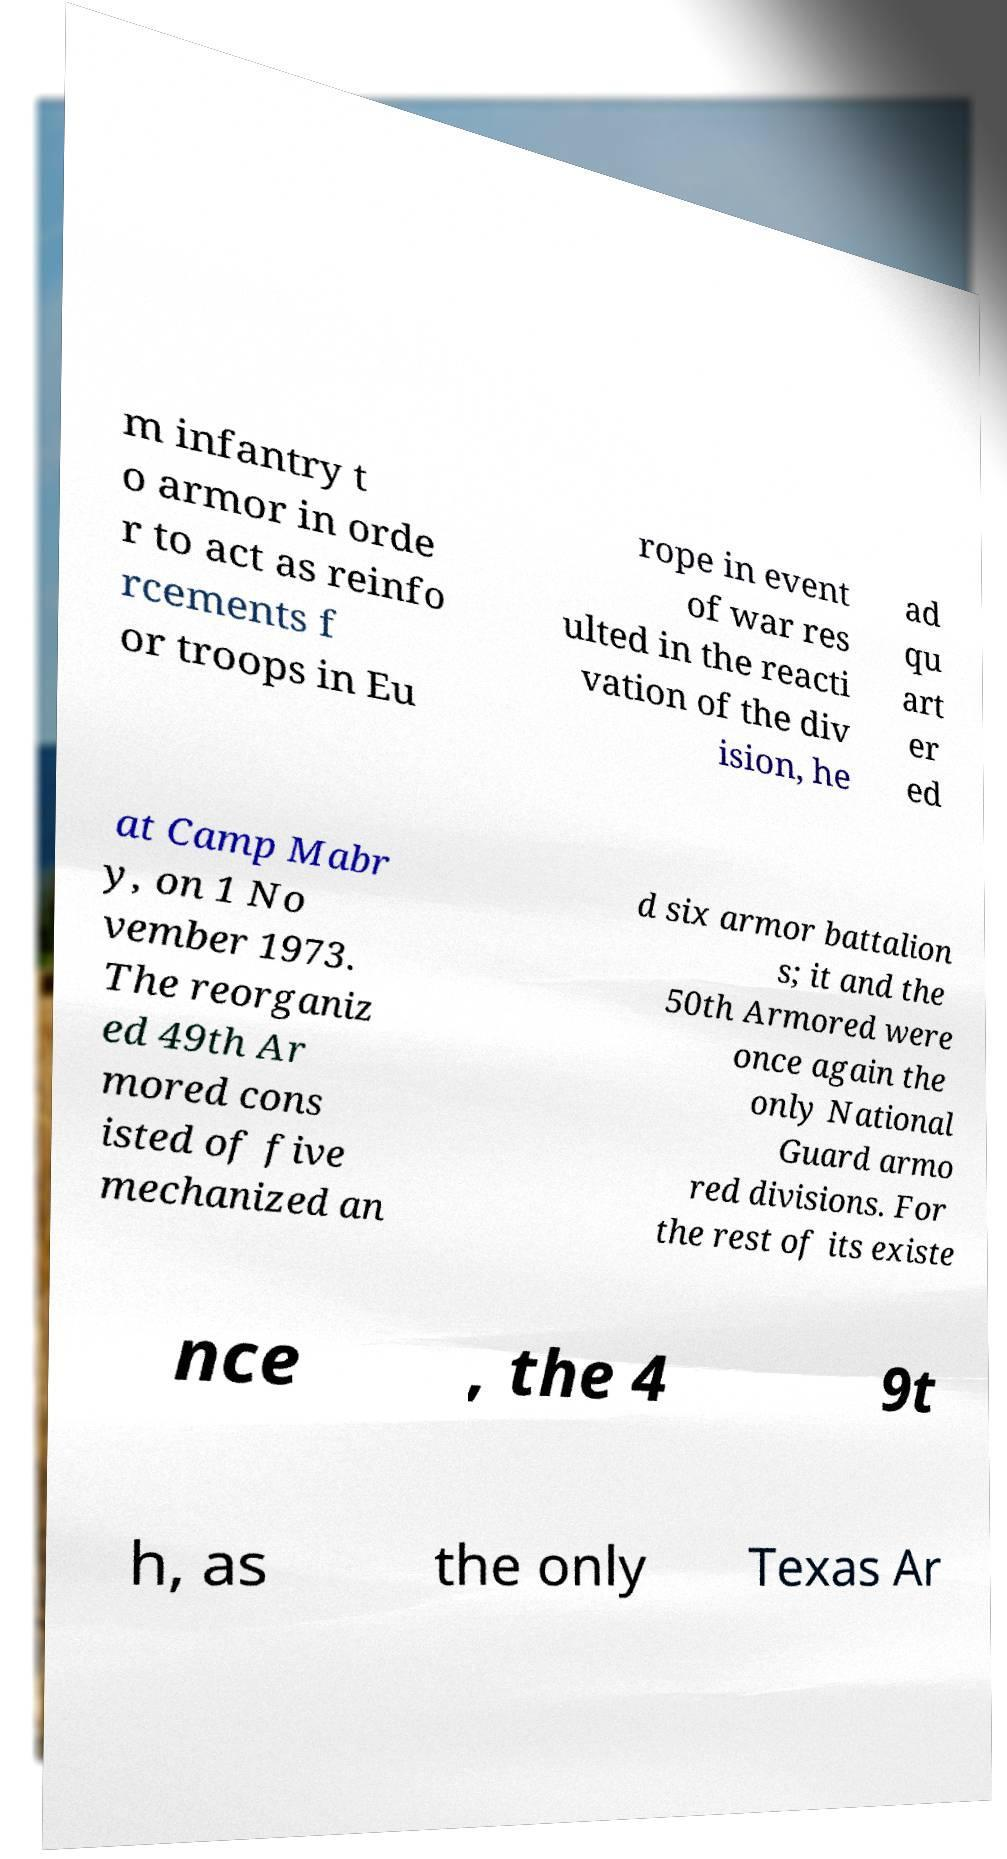Can you accurately transcribe the text from the provided image for me? m infantry t o armor in orde r to act as reinfo rcements f or troops in Eu rope in event of war res ulted in the reacti vation of the div ision, he ad qu art er ed at Camp Mabr y, on 1 No vember 1973. The reorganiz ed 49th Ar mored cons isted of five mechanized an d six armor battalion s; it and the 50th Armored were once again the only National Guard armo red divisions. For the rest of its existe nce , the 4 9t h, as the only Texas Ar 